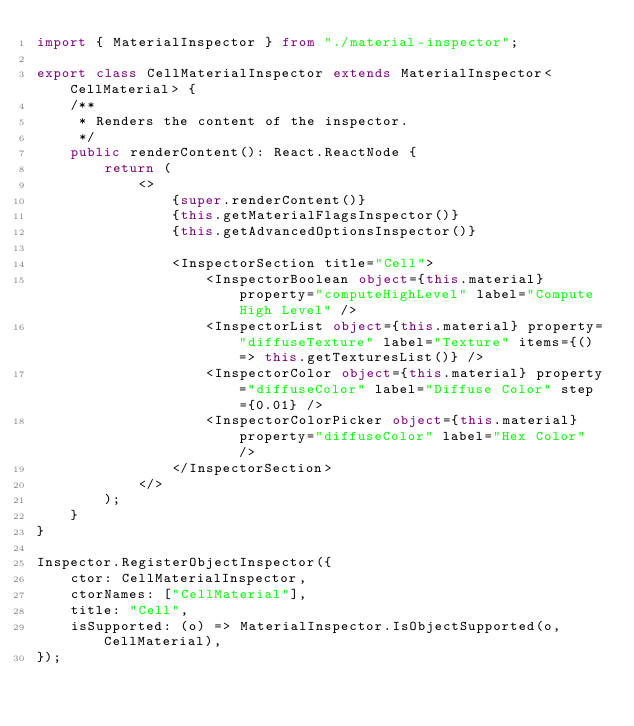Convert code to text. <code><loc_0><loc_0><loc_500><loc_500><_TypeScript_>import { MaterialInspector } from "./material-inspector";

export class CellMaterialInspector extends MaterialInspector<CellMaterial> {
    /**
     * Renders the content of the inspector.
     */
    public renderContent(): React.ReactNode {
        return (
            <>
                {super.renderContent()}
                {this.getMaterialFlagsInspector()}
                {this.getAdvancedOptionsInspector()}

                <InspectorSection title="Cell">
                    <InspectorBoolean object={this.material} property="computeHighLevel" label="Compute High Level" />
                    <InspectorList object={this.material} property="diffuseTexture" label="Texture" items={() => this.getTexturesList()} />
                    <InspectorColor object={this.material} property="diffuseColor" label="Diffuse Color" step={0.01} />
                    <InspectorColorPicker object={this.material} property="diffuseColor" label="Hex Color" />
                </InspectorSection>
            </>
        );
    }
}

Inspector.RegisterObjectInspector({
    ctor: CellMaterialInspector,
    ctorNames: ["CellMaterial"],
    title: "Cell",
    isSupported: (o) => MaterialInspector.IsObjectSupported(o, CellMaterial),
});
</code> 